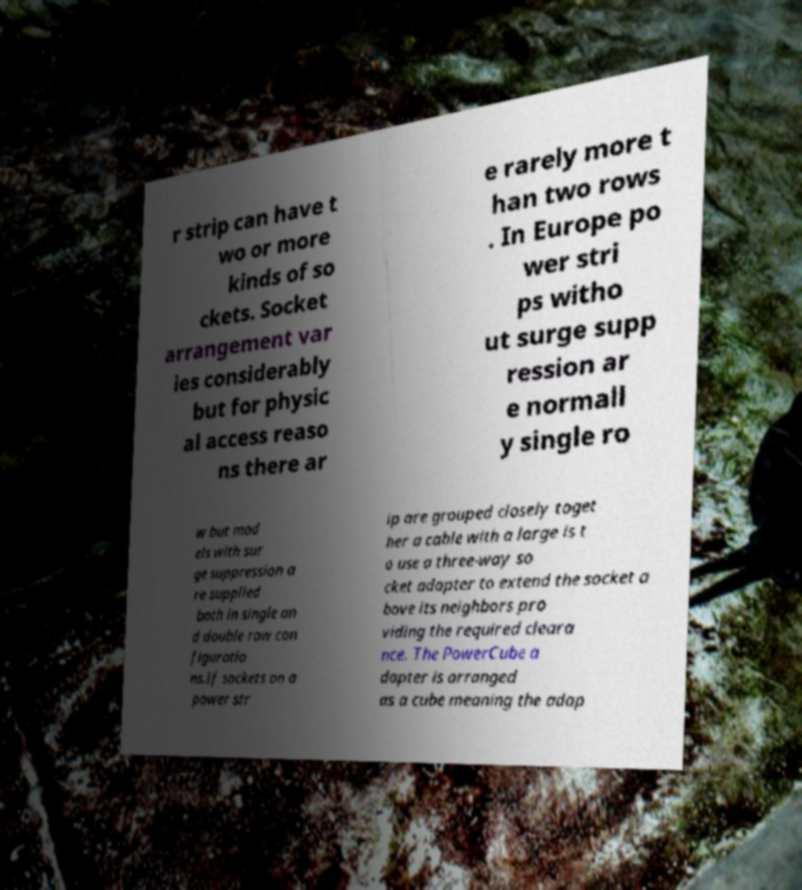Can you accurately transcribe the text from the provided image for me? r strip can have t wo or more kinds of so ckets. Socket arrangement var ies considerably but for physic al access reaso ns there ar e rarely more t han two rows . In Europe po wer stri ps witho ut surge supp ression ar e normall y single ro w but mod els with sur ge suppression a re supplied both in single an d double row con figuratio ns.If sockets on a power str ip are grouped closely toget her a cable with a large is t o use a three-way so cket adapter to extend the socket a bove its neighbors pro viding the required cleara nce. The PowerCube a dapter is arranged as a cube meaning the adap 